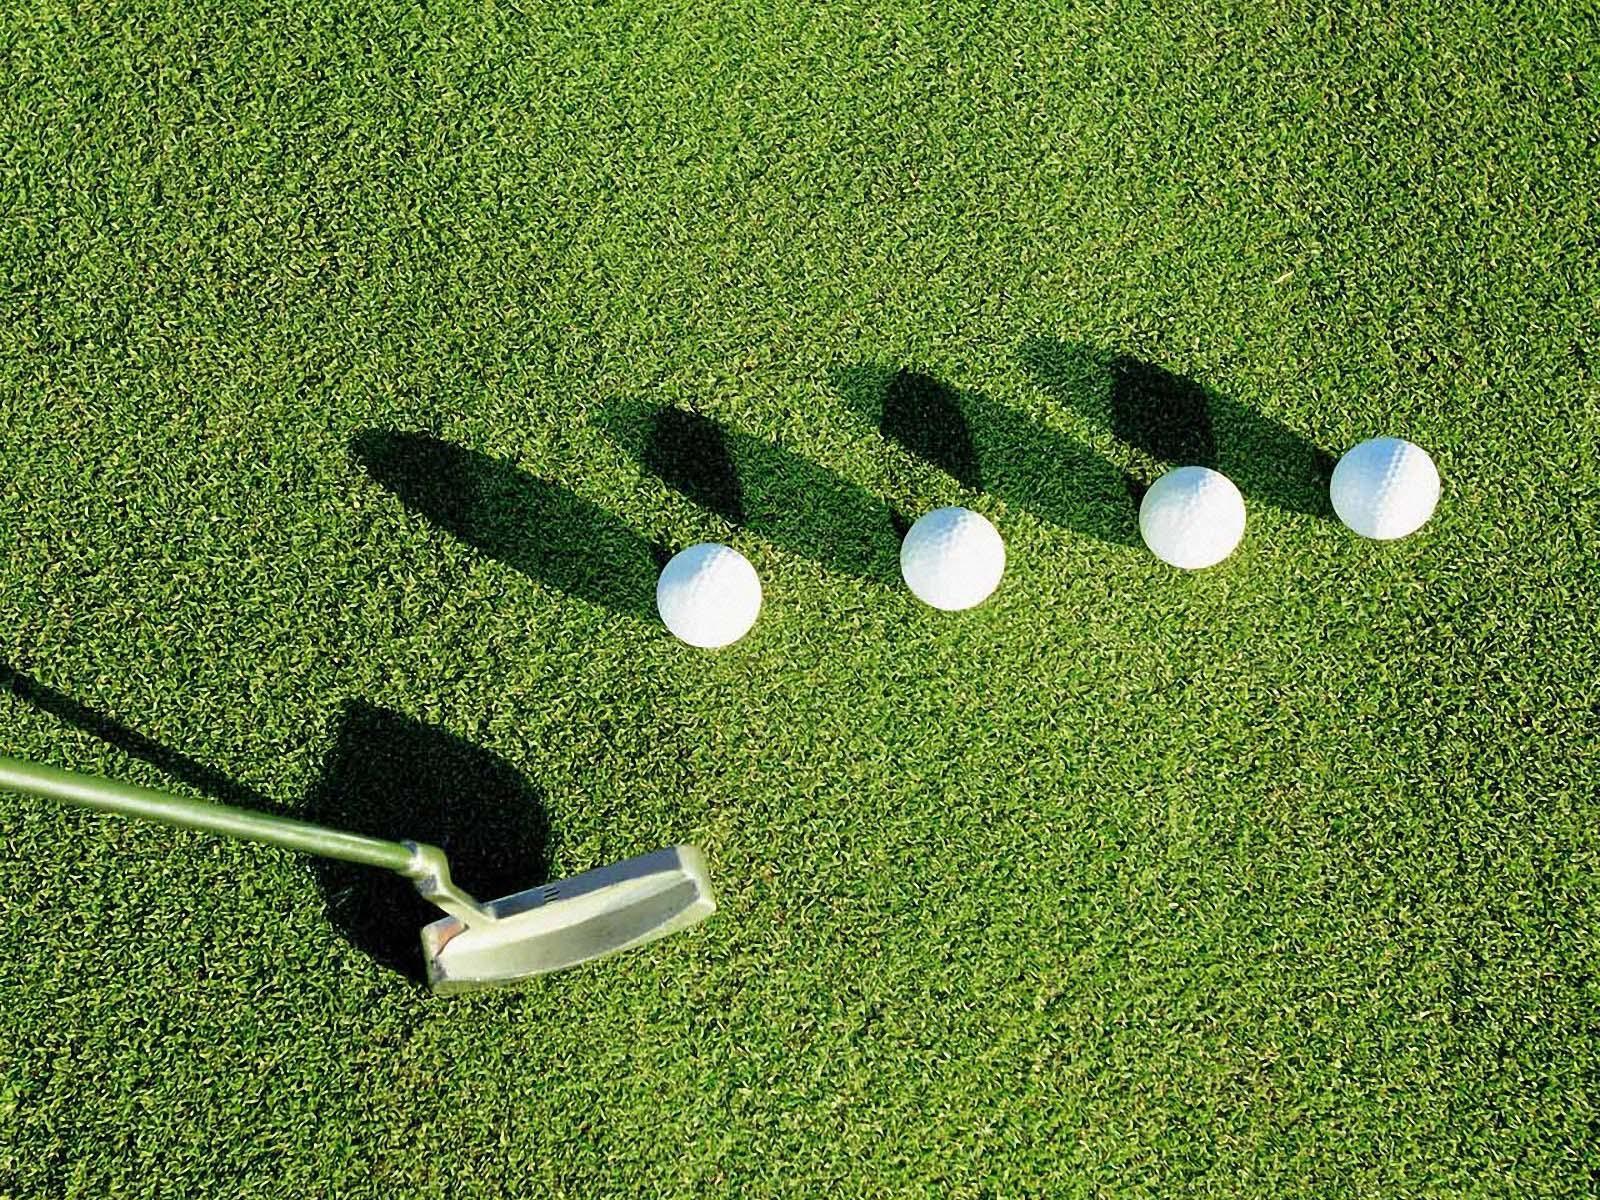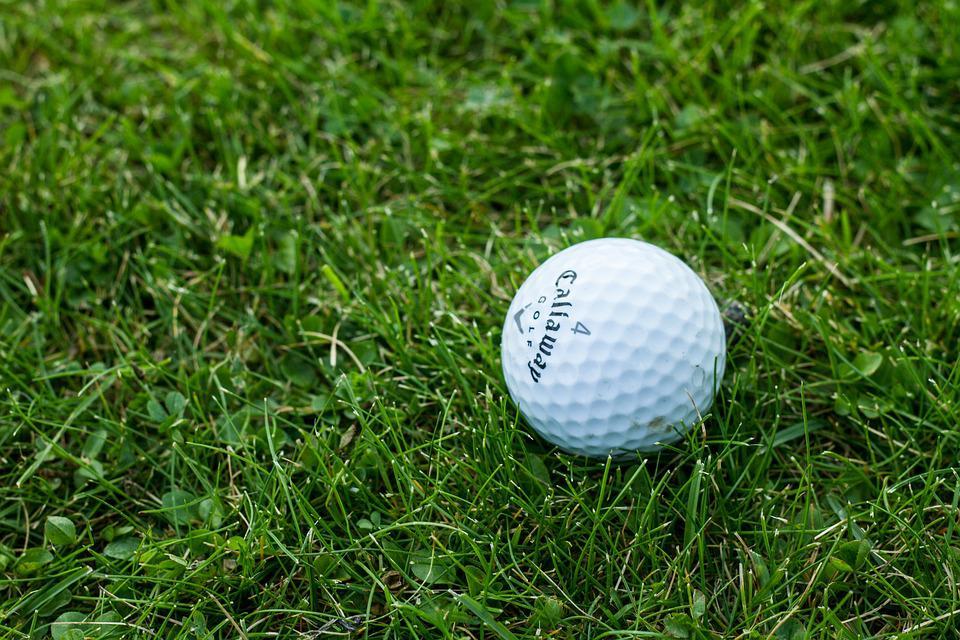The first image is the image on the left, the second image is the image on the right. Considering the images on both sides, is "in 1 of the images, 1 white golf ball is sitting in grass." valid? Answer yes or no. Yes. The first image is the image on the left, the second image is the image on the right. Considering the images on both sides, is "Exactly four golf balls are arranged on grass in one image." valid? Answer yes or no. Yes. 